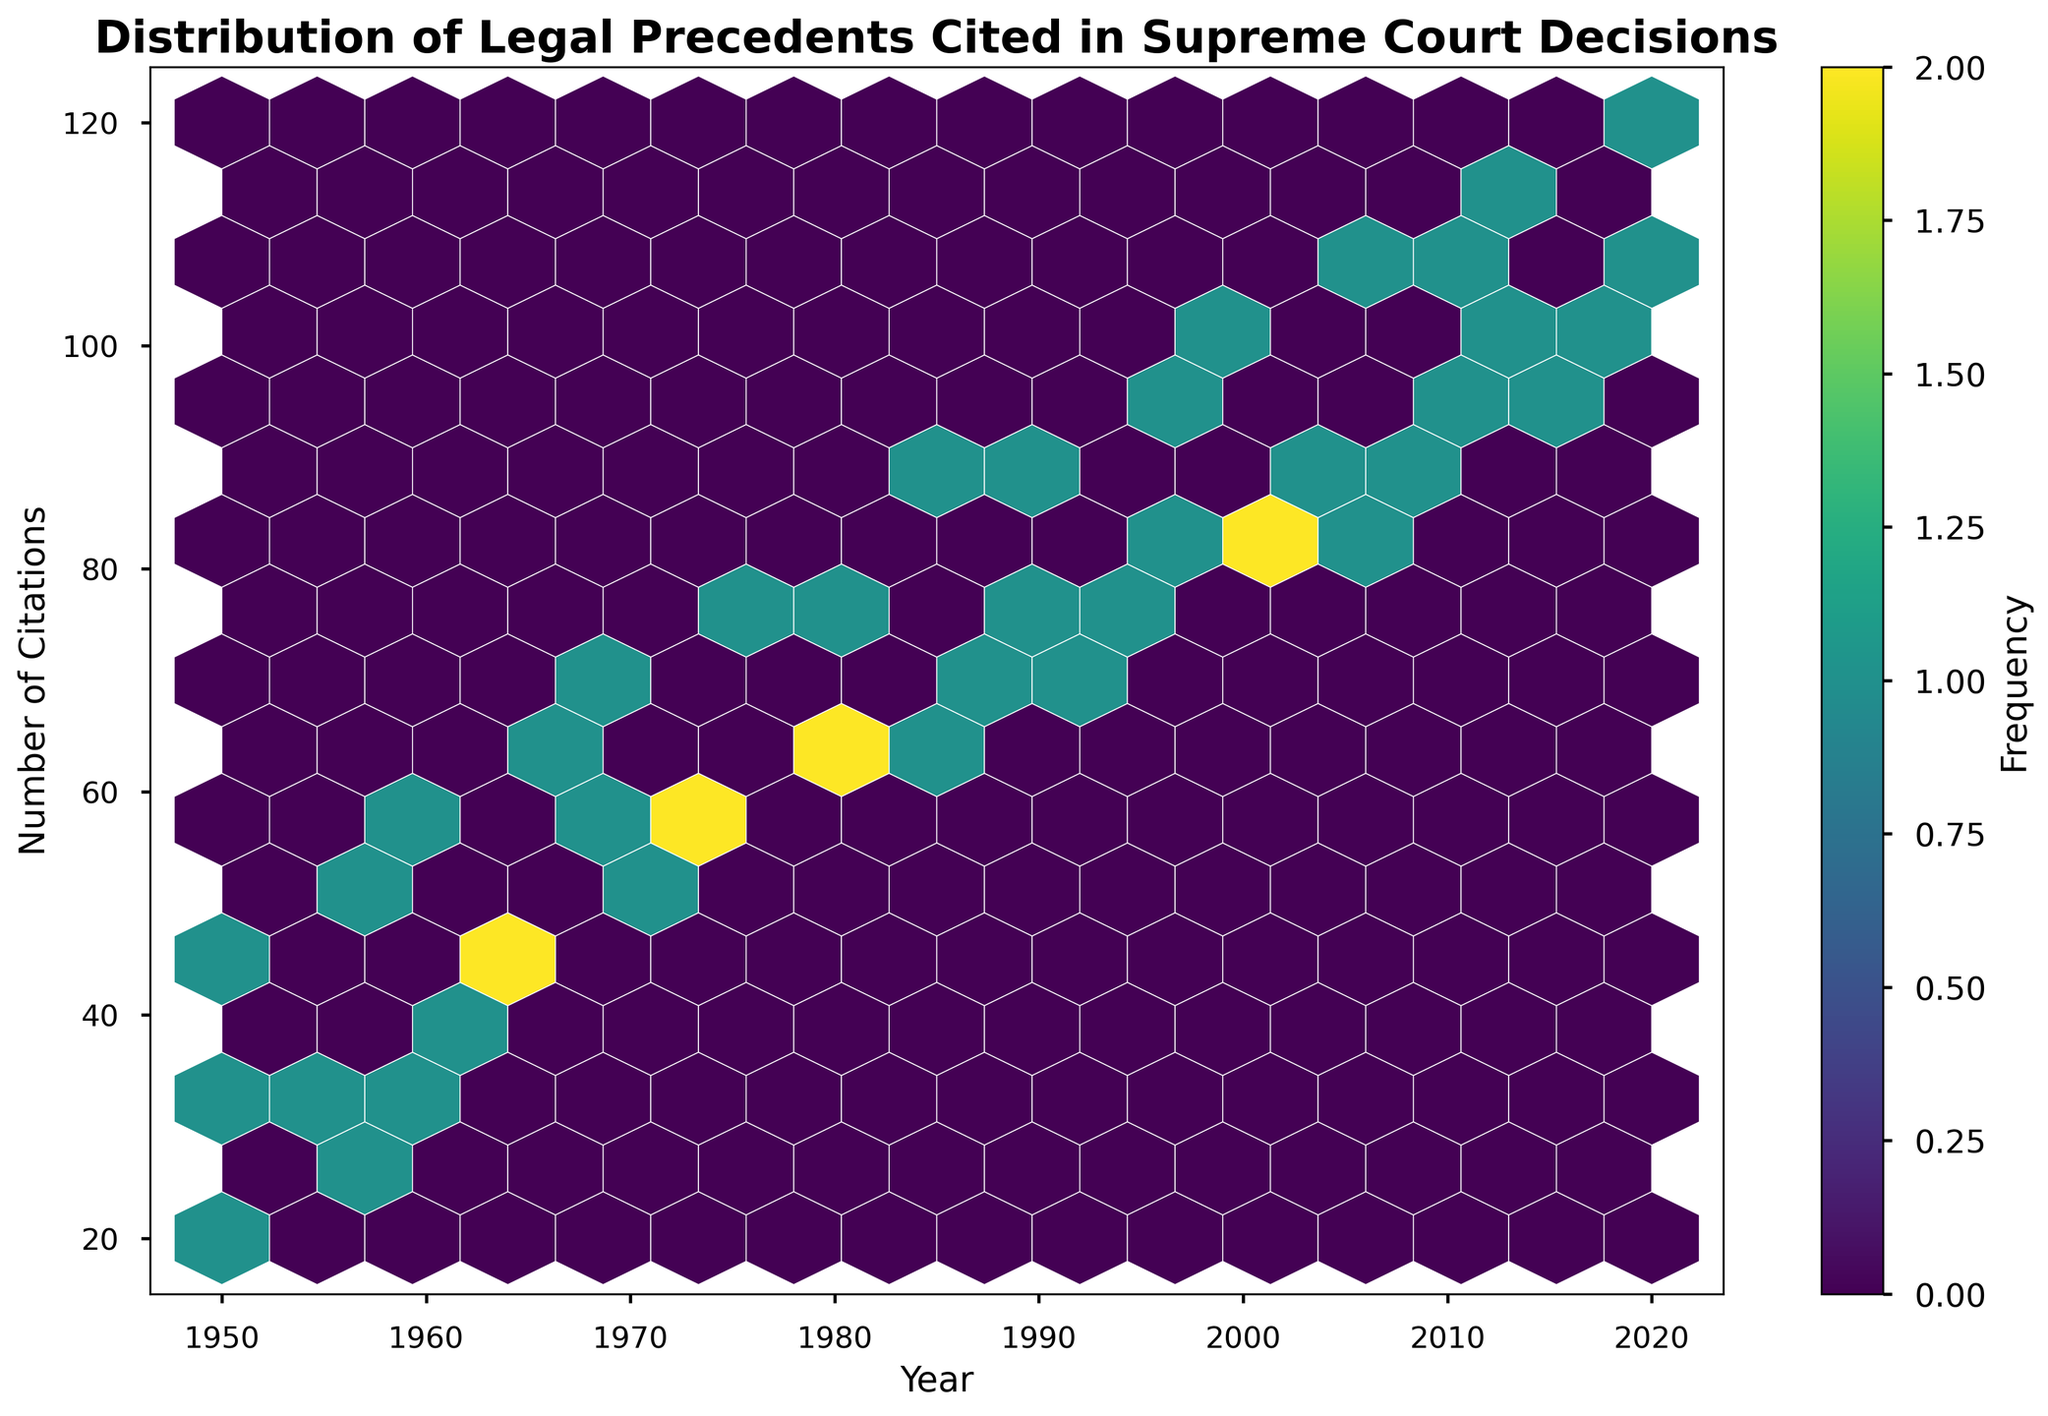What's the title of the chart? The title is typically located at the top of the chart in bold text.
Answer: Distribution of Legal Precedents Cited in Supreme Court Decisions What are the axes labels? The x-axis and y-axis labels are displayed near the bottom and left sides of the chart, respectively.
Answer: Year, Number of Citations What does the color represent in this hexbin plot? The color intensity in a hexbin plot typically indicates the frequency of data points within each hexbin.
Answer: Frequency In which decade did the number of citations for Constitutional Law appear to increase the most? By looking at the density and intensity of the hexagons, you can deduce periods of significant growth.
Answer: 1950s Which legal precedent type has the highest citation count in any year? By comparing the highest values on the y-axis for each type of legal precedent, you can identify the maximum citation count.
Answer: Constitutional Law Between the years 1970 and 1980, did Criminal Law citations increase or decrease? Find the values for Criminal Law citations in 1970 and 1980, then compare them.
Answer: Increase What is the approximate range of citation counts for Civil Rights between 2000 and 2020? Observe the distribution of Civil Rights citation counts within the specified years on the y-axis.
Answer: 85-105 Is the frequency of citations higher during the 1950s or the 2000s? Compare the density of hexagons for each decade, taking note of the color intensity.
Answer: 2000s Do any legal precedent types have overlapping citation counts in the same year? Check for any overlapping hexagons or similar citation values across different legal precedent types in the same year.
Answer: Yes Is there any notable trend in the number of citations over time across all legal precedent types? Observe the general direction of the data points across the timeline on the x-axis.
Answer: Increasing 